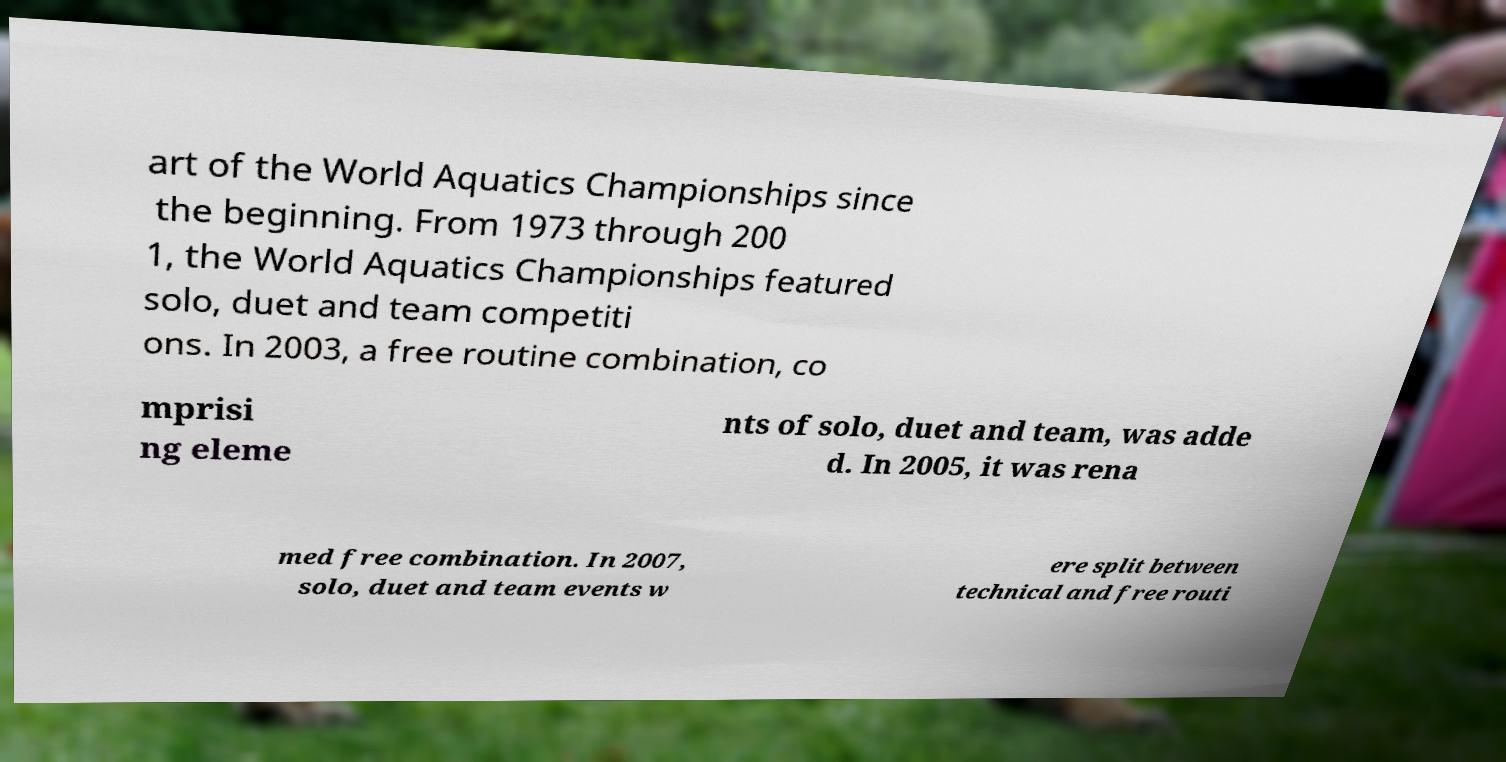Please read and relay the text visible in this image. What does it say? art of the World Aquatics Championships since the beginning. From 1973 through 200 1, the World Aquatics Championships featured solo, duet and team competiti ons. In 2003, a free routine combination, co mprisi ng eleme nts of solo, duet and team, was adde d. In 2005, it was rena med free combination. In 2007, solo, duet and team events w ere split between technical and free routi 